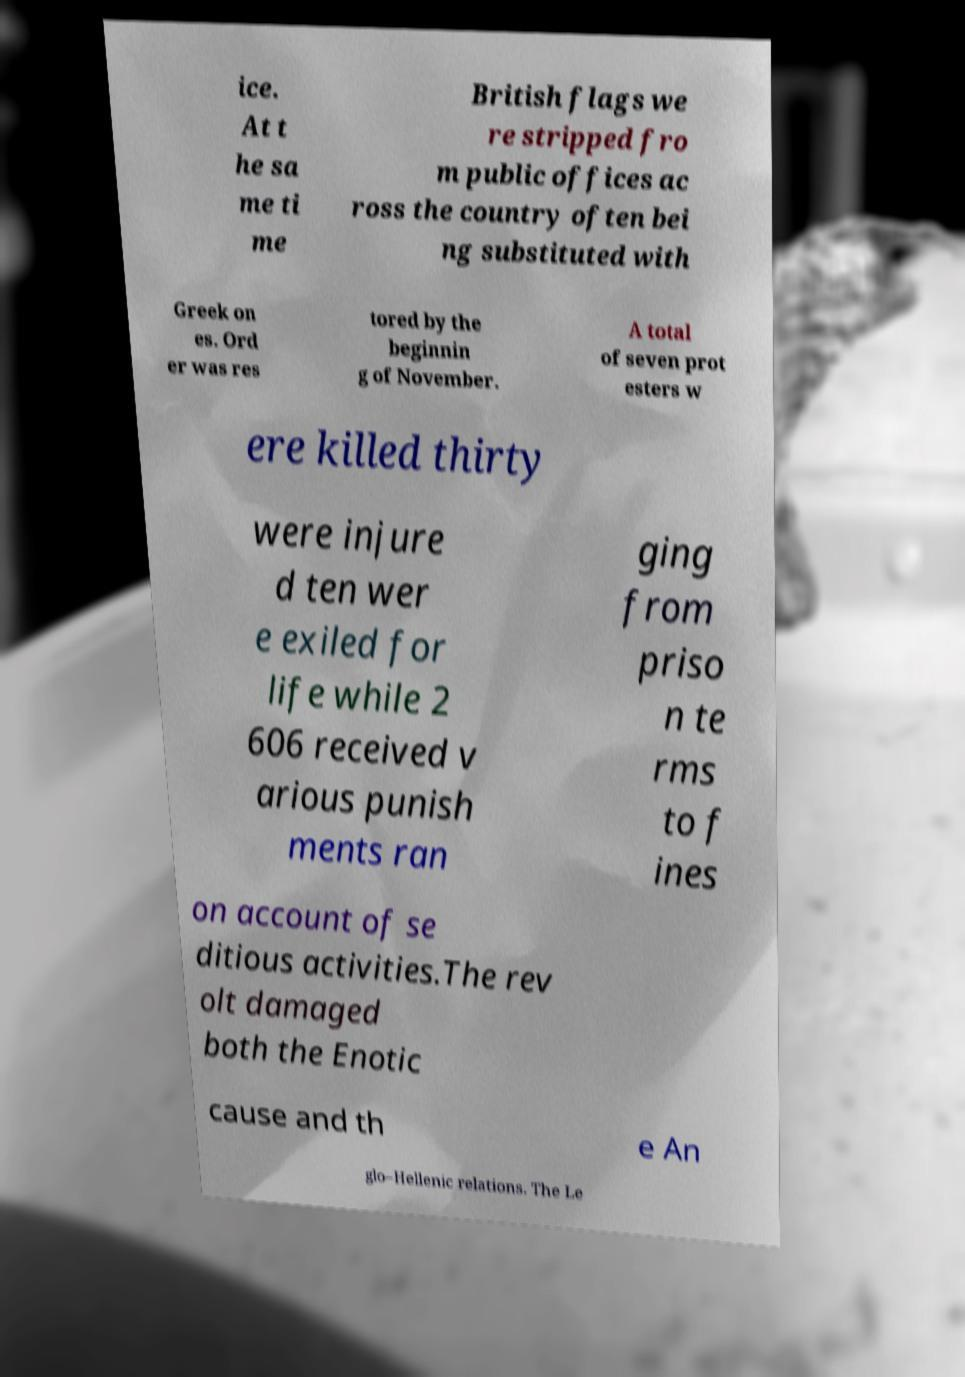Can you read and provide the text displayed in the image?This photo seems to have some interesting text. Can you extract and type it out for me? ice. At t he sa me ti me British flags we re stripped fro m public offices ac ross the country often bei ng substituted with Greek on es. Ord er was res tored by the beginnin g of November. A total of seven prot esters w ere killed thirty were injure d ten wer e exiled for life while 2 606 received v arious punish ments ran ging from priso n te rms to f ines on account of se ditious activities.The rev olt damaged both the Enotic cause and th e An glo–Hellenic relations. The Le 